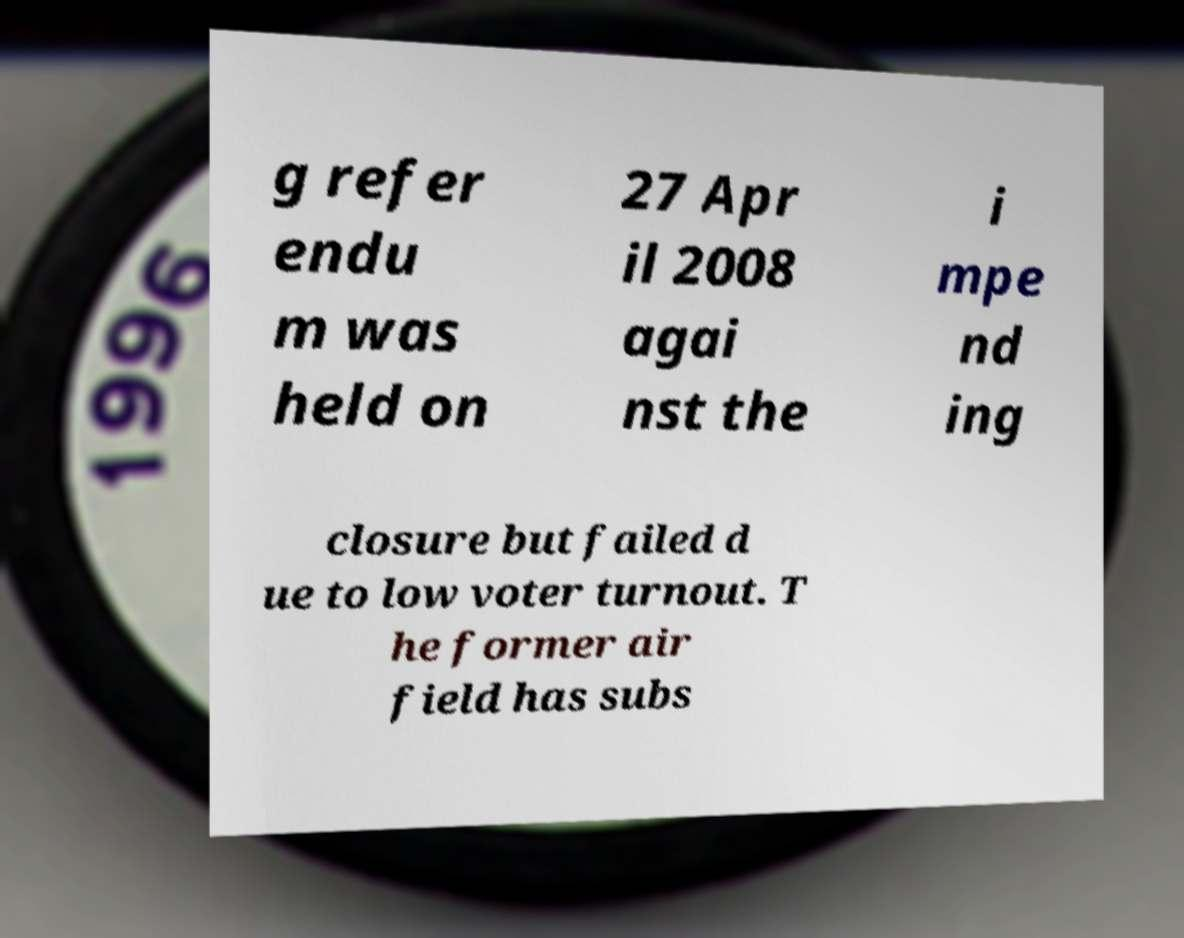Could you assist in decoding the text presented in this image and type it out clearly? g refer endu m was held on 27 Apr il 2008 agai nst the i mpe nd ing closure but failed d ue to low voter turnout. T he former air field has subs 